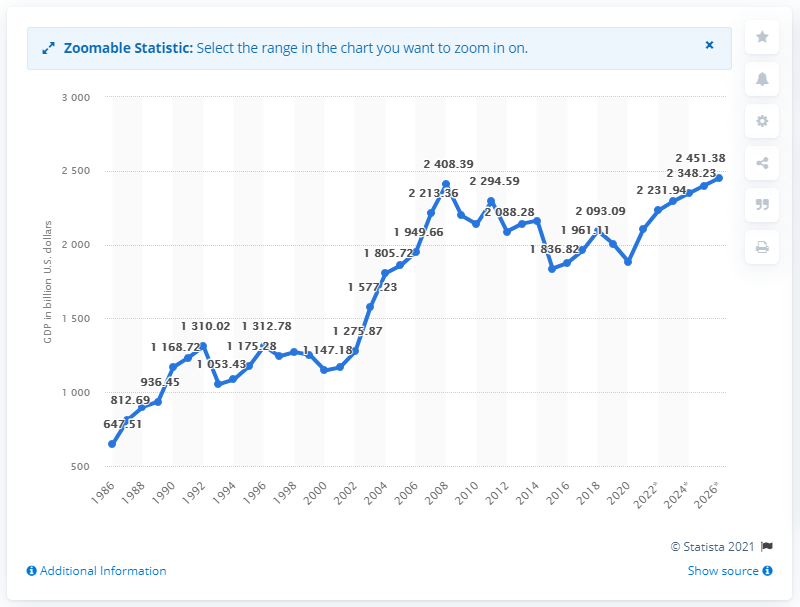List a handful of essential elements in this visual. In 2020, the Gross Domestic Product (GDP) of Italy was valued at 188.494 U.S. dollars. 